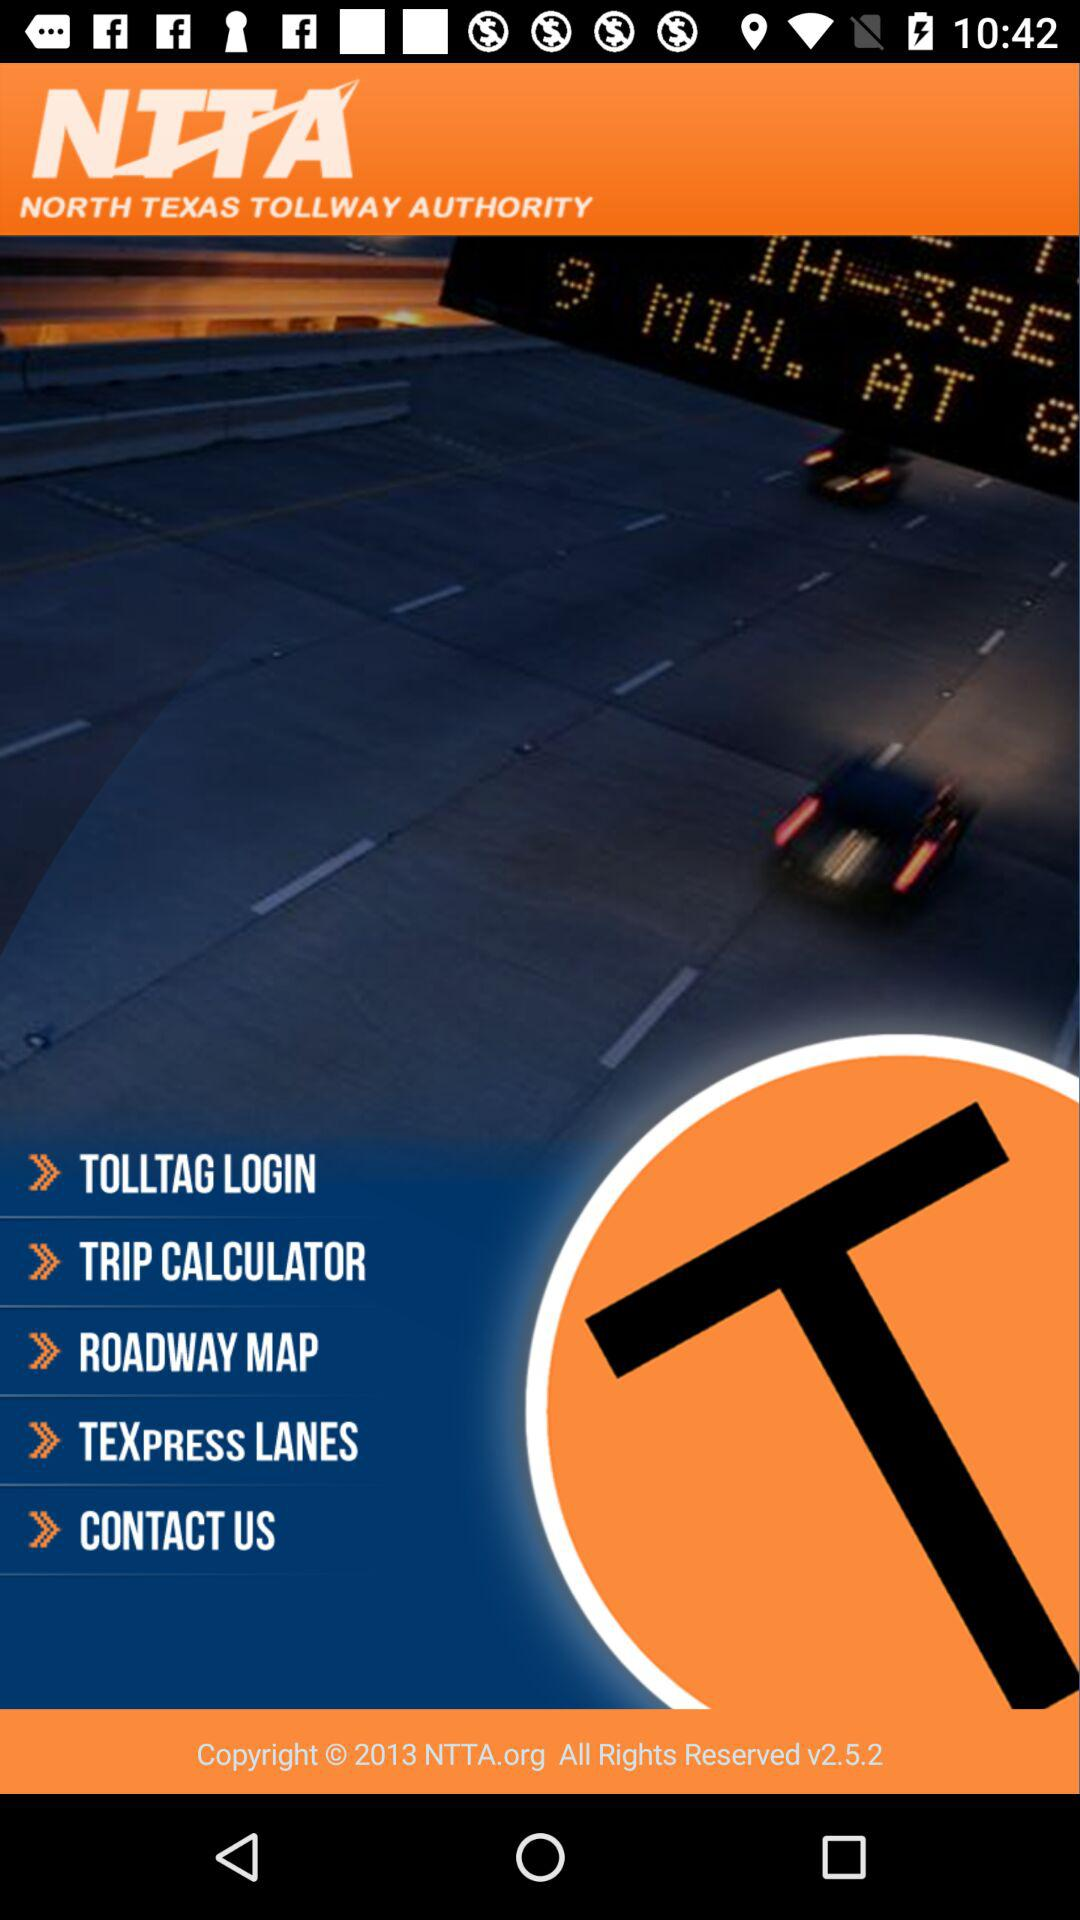What is the application name? The application name is "NTTA". 